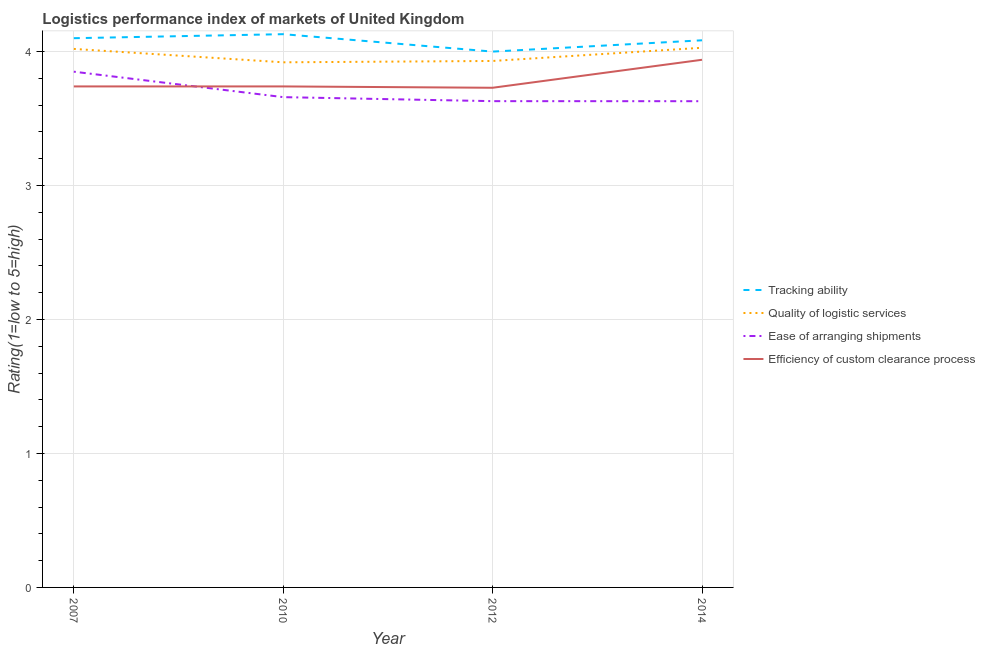How many different coloured lines are there?
Offer a terse response. 4. Is the number of lines equal to the number of legend labels?
Provide a succinct answer. Yes. What is the lpi rating of tracking ability in 2012?
Your answer should be compact. 4. Across all years, what is the maximum lpi rating of tracking ability?
Provide a succinct answer. 4.13. What is the total lpi rating of ease of arranging shipments in the graph?
Offer a terse response. 14.77. What is the difference between the lpi rating of ease of arranging shipments in 2007 and that in 2014?
Provide a succinct answer. 0.22. What is the difference between the lpi rating of tracking ability in 2012 and the lpi rating of efficiency of custom clearance process in 2010?
Give a very brief answer. 0.26. What is the average lpi rating of quality of logistic services per year?
Ensure brevity in your answer.  3.97. In the year 2012, what is the difference between the lpi rating of tracking ability and lpi rating of efficiency of custom clearance process?
Keep it short and to the point. 0.27. In how many years, is the lpi rating of tracking ability greater than 3?
Provide a succinct answer. 4. What is the ratio of the lpi rating of efficiency of custom clearance process in 2010 to that in 2014?
Ensure brevity in your answer.  0.95. Is the lpi rating of ease of arranging shipments in 2007 less than that in 2010?
Give a very brief answer. No. What is the difference between the highest and the second highest lpi rating of tracking ability?
Ensure brevity in your answer.  0.03. What is the difference between the highest and the lowest lpi rating of ease of arranging shipments?
Provide a short and direct response. 0.22. In how many years, is the lpi rating of efficiency of custom clearance process greater than the average lpi rating of efficiency of custom clearance process taken over all years?
Your answer should be compact. 1. Is it the case that in every year, the sum of the lpi rating of tracking ability and lpi rating of quality of logistic services is greater than the lpi rating of ease of arranging shipments?
Offer a very short reply. Yes. How many lines are there?
Provide a succinct answer. 4. What is the difference between two consecutive major ticks on the Y-axis?
Your response must be concise. 1. Are the values on the major ticks of Y-axis written in scientific E-notation?
Your answer should be compact. No. Does the graph contain any zero values?
Your response must be concise. No. Where does the legend appear in the graph?
Give a very brief answer. Center right. How are the legend labels stacked?
Ensure brevity in your answer.  Vertical. What is the title of the graph?
Your answer should be compact. Logistics performance index of markets of United Kingdom. What is the label or title of the X-axis?
Your response must be concise. Year. What is the label or title of the Y-axis?
Keep it short and to the point. Rating(1=low to 5=high). What is the Rating(1=low to 5=high) in Tracking ability in 2007?
Your response must be concise. 4.1. What is the Rating(1=low to 5=high) in Quality of logistic services in 2007?
Give a very brief answer. 4.02. What is the Rating(1=low to 5=high) of Ease of arranging shipments in 2007?
Keep it short and to the point. 3.85. What is the Rating(1=low to 5=high) of Efficiency of custom clearance process in 2007?
Provide a short and direct response. 3.74. What is the Rating(1=low to 5=high) of Tracking ability in 2010?
Give a very brief answer. 4.13. What is the Rating(1=low to 5=high) in Quality of logistic services in 2010?
Your response must be concise. 3.92. What is the Rating(1=low to 5=high) in Ease of arranging shipments in 2010?
Make the answer very short. 3.66. What is the Rating(1=low to 5=high) of Efficiency of custom clearance process in 2010?
Provide a succinct answer. 3.74. What is the Rating(1=low to 5=high) in Tracking ability in 2012?
Give a very brief answer. 4. What is the Rating(1=low to 5=high) in Quality of logistic services in 2012?
Ensure brevity in your answer.  3.93. What is the Rating(1=low to 5=high) of Ease of arranging shipments in 2012?
Provide a short and direct response. 3.63. What is the Rating(1=low to 5=high) of Efficiency of custom clearance process in 2012?
Your answer should be very brief. 3.73. What is the Rating(1=low to 5=high) in Tracking ability in 2014?
Your response must be concise. 4.08. What is the Rating(1=low to 5=high) in Quality of logistic services in 2014?
Give a very brief answer. 4.03. What is the Rating(1=low to 5=high) of Ease of arranging shipments in 2014?
Offer a terse response. 3.63. What is the Rating(1=low to 5=high) in Efficiency of custom clearance process in 2014?
Make the answer very short. 3.94. Across all years, what is the maximum Rating(1=low to 5=high) in Tracking ability?
Make the answer very short. 4.13. Across all years, what is the maximum Rating(1=low to 5=high) of Quality of logistic services?
Your answer should be very brief. 4.03. Across all years, what is the maximum Rating(1=low to 5=high) of Ease of arranging shipments?
Provide a short and direct response. 3.85. Across all years, what is the maximum Rating(1=low to 5=high) in Efficiency of custom clearance process?
Make the answer very short. 3.94. Across all years, what is the minimum Rating(1=low to 5=high) in Tracking ability?
Give a very brief answer. 4. Across all years, what is the minimum Rating(1=low to 5=high) in Quality of logistic services?
Provide a succinct answer. 3.92. Across all years, what is the minimum Rating(1=low to 5=high) in Ease of arranging shipments?
Make the answer very short. 3.63. Across all years, what is the minimum Rating(1=low to 5=high) of Efficiency of custom clearance process?
Your response must be concise. 3.73. What is the total Rating(1=low to 5=high) in Tracking ability in the graph?
Offer a very short reply. 16.31. What is the total Rating(1=low to 5=high) in Quality of logistic services in the graph?
Ensure brevity in your answer.  15.9. What is the total Rating(1=low to 5=high) in Ease of arranging shipments in the graph?
Provide a succinct answer. 14.77. What is the total Rating(1=low to 5=high) of Efficiency of custom clearance process in the graph?
Keep it short and to the point. 15.15. What is the difference between the Rating(1=low to 5=high) in Tracking ability in 2007 and that in 2010?
Give a very brief answer. -0.03. What is the difference between the Rating(1=low to 5=high) in Ease of arranging shipments in 2007 and that in 2010?
Provide a short and direct response. 0.19. What is the difference between the Rating(1=low to 5=high) of Quality of logistic services in 2007 and that in 2012?
Provide a short and direct response. 0.09. What is the difference between the Rating(1=low to 5=high) of Ease of arranging shipments in 2007 and that in 2012?
Your answer should be compact. 0.22. What is the difference between the Rating(1=low to 5=high) of Efficiency of custom clearance process in 2007 and that in 2012?
Make the answer very short. 0.01. What is the difference between the Rating(1=low to 5=high) of Tracking ability in 2007 and that in 2014?
Your answer should be very brief. 0.02. What is the difference between the Rating(1=low to 5=high) in Quality of logistic services in 2007 and that in 2014?
Your answer should be very brief. -0.01. What is the difference between the Rating(1=low to 5=high) of Ease of arranging shipments in 2007 and that in 2014?
Your answer should be compact. 0.22. What is the difference between the Rating(1=low to 5=high) of Efficiency of custom clearance process in 2007 and that in 2014?
Ensure brevity in your answer.  -0.2. What is the difference between the Rating(1=low to 5=high) in Tracking ability in 2010 and that in 2012?
Offer a very short reply. 0.13. What is the difference between the Rating(1=low to 5=high) of Quality of logistic services in 2010 and that in 2012?
Make the answer very short. -0.01. What is the difference between the Rating(1=low to 5=high) of Tracking ability in 2010 and that in 2014?
Give a very brief answer. 0.05. What is the difference between the Rating(1=low to 5=high) of Quality of logistic services in 2010 and that in 2014?
Offer a terse response. -0.11. What is the difference between the Rating(1=low to 5=high) of Ease of arranging shipments in 2010 and that in 2014?
Provide a succinct answer. 0.03. What is the difference between the Rating(1=low to 5=high) of Efficiency of custom clearance process in 2010 and that in 2014?
Ensure brevity in your answer.  -0.2. What is the difference between the Rating(1=low to 5=high) of Tracking ability in 2012 and that in 2014?
Provide a short and direct response. -0.08. What is the difference between the Rating(1=low to 5=high) of Quality of logistic services in 2012 and that in 2014?
Keep it short and to the point. -0.1. What is the difference between the Rating(1=low to 5=high) of Efficiency of custom clearance process in 2012 and that in 2014?
Give a very brief answer. -0.21. What is the difference between the Rating(1=low to 5=high) in Tracking ability in 2007 and the Rating(1=low to 5=high) in Quality of logistic services in 2010?
Your answer should be compact. 0.18. What is the difference between the Rating(1=low to 5=high) in Tracking ability in 2007 and the Rating(1=low to 5=high) in Ease of arranging shipments in 2010?
Keep it short and to the point. 0.44. What is the difference between the Rating(1=low to 5=high) in Tracking ability in 2007 and the Rating(1=low to 5=high) in Efficiency of custom clearance process in 2010?
Provide a short and direct response. 0.36. What is the difference between the Rating(1=low to 5=high) of Quality of logistic services in 2007 and the Rating(1=low to 5=high) of Ease of arranging shipments in 2010?
Give a very brief answer. 0.36. What is the difference between the Rating(1=low to 5=high) of Quality of logistic services in 2007 and the Rating(1=low to 5=high) of Efficiency of custom clearance process in 2010?
Give a very brief answer. 0.28. What is the difference between the Rating(1=low to 5=high) of Ease of arranging shipments in 2007 and the Rating(1=low to 5=high) of Efficiency of custom clearance process in 2010?
Ensure brevity in your answer.  0.11. What is the difference between the Rating(1=low to 5=high) in Tracking ability in 2007 and the Rating(1=low to 5=high) in Quality of logistic services in 2012?
Your response must be concise. 0.17. What is the difference between the Rating(1=low to 5=high) in Tracking ability in 2007 and the Rating(1=low to 5=high) in Ease of arranging shipments in 2012?
Your response must be concise. 0.47. What is the difference between the Rating(1=low to 5=high) of Tracking ability in 2007 and the Rating(1=low to 5=high) of Efficiency of custom clearance process in 2012?
Provide a short and direct response. 0.37. What is the difference between the Rating(1=low to 5=high) of Quality of logistic services in 2007 and the Rating(1=low to 5=high) of Ease of arranging shipments in 2012?
Your answer should be very brief. 0.39. What is the difference between the Rating(1=low to 5=high) in Quality of logistic services in 2007 and the Rating(1=low to 5=high) in Efficiency of custom clearance process in 2012?
Make the answer very short. 0.29. What is the difference between the Rating(1=low to 5=high) of Ease of arranging shipments in 2007 and the Rating(1=low to 5=high) of Efficiency of custom clearance process in 2012?
Make the answer very short. 0.12. What is the difference between the Rating(1=low to 5=high) in Tracking ability in 2007 and the Rating(1=low to 5=high) in Quality of logistic services in 2014?
Your answer should be compact. 0.07. What is the difference between the Rating(1=low to 5=high) in Tracking ability in 2007 and the Rating(1=low to 5=high) in Ease of arranging shipments in 2014?
Give a very brief answer. 0.47. What is the difference between the Rating(1=low to 5=high) of Tracking ability in 2007 and the Rating(1=low to 5=high) of Efficiency of custom clearance process in 2014?
Your answer should be compact. 0.16. What is the difference between the Rating(1=low to 5=high) in Quality of logistic services in 2007 and the Rating(1=low to 5=high) in Ease of arranging shipments in 2014?
Make the answer very short. 0.39. What is the difference between the Rating(1=low to 5=high) of Quality of logistic services in 2007 and the Rating(1=low to 5=high) of Efficiency of custom clearance process in 2014?
Your response must be concise. 0.08. What is the difference between the Rating(1=low to 5=high) of Ease of arranging shipments in 2007 and the Rating(1=low to 5=high) of Efficiency of custom clearance process in 2014?
Provide a succinct answer. -0.09. What is the difference between the Rating(1=low to 5=high) in Tracking ability in 2010 and the Rating(1=low to 5=high) in Quality of logistic services in 2012?
Offer a terse response. 0.2. What is the difference between the Rating(1=low to 5=high) in Tracking ability in 2010 and the Rating(1=low to 5=high) in Ease of arranging shipments in 2012?
Offer a terse response. 0.5. What is the difference between the Rating(1=low to 5=high) in Tracking ability in 2010 and the Rating(1=low to 5=high) in Efficiency of custom clearance process in 2012?
Offer a terse response. 0.4. What is the difference between the Rating(1=low to 5=high) in Quality of logistic services in 2010 and the Rating(1=low to 5=high) in Ease of arranging shipments in 2012?
Offer a terse response. 0.29. What is the difference between the Rating(1=low to 5=high) in Quality of logistic services in 2010 and the Rating(1=low to 5=high) in Efficiency of custom clearance process in 2012?
Your answer should be compact. 0.19. What is the difference between the Rating(1=low to 5=high) in Ease of arranging shipments in 2010 and the Rating(1=low to 5=high) in Efficiency of custom clearance process in 2012?
Keep it short and to the point. -0.07. What is the difference between the Rating(1=low to 5=high) in Tracking ability in 2010 and the Rating(1=low to 5=high) in Quality of logistic services in 2014?
Give a very brief answer. 0.1. What is the difference between the Rating(1=low to 5=high) in Tracking ability in 2010 and the Rating(1=low to 5=high) in Ease of arranging shipments in 2014?
Offer a terse response. 0.5. What is the difference between the Rating(1=low to 5=high) of Tracking ability in 2010 and the Rating(1=low to 5=high) of Efficiency of custom clearance process in 2014?
Keep it short and to the point. 0.19. What is the difference between the Rating(1=low to 5=high) in Quality of logistic services in 2010 and the Rating(1=low to 5=high) in Ease of arranging shipments in 2014?
Offer a very short reply. 0.29. What is the difference between the Rating(1=low to 5=high) in Quality of logistic services in 2010 and the Rating(1=low to 5=high) in Efficiency of custom clearance process in 2014?
Provide a short and direct response. -0.02. What is the difference between the Rating(1=low to 5=high) of Ease of arranging shipments in 2010 and the Rating(1=low to 5=high) of Efficiency of custom clearance process in 2014?
Give a very brief answer. -0.28. What is the difference between the Rating(1=low to 5=high) of Tracking ability in 2012 and the Rating(1=low to 5=high) of Quality of logistic services in 2014?
Ensure brevity in your answer.  -0.03. What is the difference between the Rating(1=low to 5=high) in Tracking ability in 2012 and the Rating(1=low to 5=high) in Ease of arranging shipments in 2014?
Provide a short and direct response. 0.37. What is the difference between the Rating(1=low to 5=high) of Tracking ability in 2012 and the Rating(1=low to 5=high) of Efficiency of custom clearance process in 2014?
Make the answer very short. 0.06. What is the difference between the Rating(1=low to 5=high) of Quality of logistic services in 2012 and the Rating(1=low to 5=high) of Ease of arranging shipments in 2014?
Provide a succinct answer. 0.3. What is the difference between the Rating(1=low to 5=high) of Quality of logistic services in 2012 and the Rating(1=low to 5=high) of Efficiency of custom clearance process in 2014?
Keep it short and to the point. -0.01. What is the difference between the Rating(1=low to 5=high) of Ease of arranging shipments in 2012 and the Rating(1=low to 5=high) of Efficiency of custom clearance process in 2014?
Your answer should be very brief. -0.31. What is the average Rating(1=low to 5=high) in Tracking ability per year?
Make the answer very short. 4.08. What is the average Rating(1=low to 5=high) of Quality of logistic services per year?
Provide a short and direct response. 3.97. What is the average Rating(1=low to 5=high) in Ease of arranging shipments per year?
Offer a very short reply. 3.69. What is the average Rating(1=low to 5=high) of Efficiency of custom clearance process per year?
Give a very brief answer. 3.79. In the year 2007, what is the difference between the Rating(1=low to 5=high) in Tracking ability and Rating(1=low to 5=high) in Quality of logistic services?
Make the answer very short. 0.08. In the year 2007, what is the difference between the Rating(1=low to 5=high) in Tracking ability and Rating(1=low to 5=high) in Ease of arranging shipments?
Keep it short and to the point. 0.25. In the year 2007, what is the difference between the Rating(1=low to 5=high) in Tracking ability and Rating(1=low to 5=high) in Efficiency of custom clearance process?
Provide a short and direct response. 0.36. In the year 2007, what is the difference between the Rating(1=low to 5=high) in Quality of logistic services and Rating(1=low to 5=high) in Ease of arranging shipments?
Offer a terse response. 0.17. In the year 2007, what is the difference between the Rating(1=low to 5=high) in Quality of logistic services and Rating(1=low to 5=high) in Efficiency of custom clearance process?
Keep it short and to the point. 0.28. In the year 2007, what is the difference between the Rating(1=low to 5=high) in Ease of arranging shipments and Rating(1=low to 5=high) in Efficiency of custom clearance process?
Your answer should be compact. 0.11. In the year 2010, what is the difference between the Rating(1=low to 5=high) of Tracking ability and Rating(1=low to 5=high) of Quality of logistic services?
Give a very brief answer. 0.21. In the year 2010, what is the difference between the Rating(1=low to 5=high) in Tracking ability and Rating(1=low to 5=high) in Ease of arranging shipments?
Your answer should be compact. 0.47. In the year 2010, what is the difference between the Rating(1=low to 5=high) in Tracking ability and Rating(1=low to 5=high) in Efficiency of custom clearance process?
Ensure brevity in your answer.  0.39. In the year 2010, what is the difference between the Rating(1=low to 5=high) of Quality of logistic services and Rating(1=low to 5=high) of Ease of arranging shipments?
Your answer should be compact. 0.26. In the year 2010, what is the difference between the Rating(1=low to 5=high) of Quality of logistic services and Rating(1=low to 5=high) of Efficiency of custom clearance process?
Provide a succinct answer. 0.18. In the year 2010, what is the difference between the Rating(1=low to 5=high) of Ease of arranging shipments and Rating(1=low to 5=high) of Efficiency of custom clearance process?
Your response must be concise. -0.08. In the year 2012, what is the difference between the Rating(1=low to 5=high) in Tracking ability and Rating(1=low to 5=high) in Quality of logistic services?
Your response must be concise. 0.07. In the year 2012, what is the difference between the Rating(1=low to 5=high) of Tracking ability and Rating(1=low to 5=high) of Ease of arranging shipments?
Make the answer very short. 0.37. In the year 2012, what is the difference between the Rating(1=low to 5=high) of Tracking ability and Rating(1=low to 5=high) of Efficiency of custom clearance process?
Provide a succinct answer. 0.27. In the year 2012, what is the difference between the Rating(1=low to 5=high) of Quality of logistic services and Rating(1=low to 5=high) of Ease of arranging shipments?
Provide a succinct answer. 0.3. In the year 2012, what is the difference between the Rating(1=low to 5=high) of Ease of arranging shipments and Rating(1=low to 5=high) of Efficiency of custom clearance process?
Provide a short and direct response. -0.1. In the year 2014, what is the difference between the Rating(1=low to 5=high) in Tracking ability and Rating(1=low to 5=high) in Quality of logistic services?
Give a very brief answer. 0.06. In the year 2014, what is the difference between the Rating(1=low to 5=high) in Tracking ability and Rating(1=low to 5=high) in Ease of arranging shipments?
Ensure brevity in your answer.  0.45. In the year 2014, what is the difference between the Rating(1=low to 5=high) of Tracking ability and Rating(1=low to 5=high) of Efficiency of custom clearance process?
Provide a short and direct response. 0.15. In the year 2014, what is the difference between the Rating(1=low to 5=high) in Quality of logistic services and Rating(1=low to 5=high) in Ease of arranging shipments?
Provide a succinct answer. 0.4. In the year 2014, what is the difference between the Rating(1=low to 5=high) of Quality of logistic services and Rating(1=low to 5=high) of Efficiency of custom clearance process?
Your response must be concise. 0.09. In the year 2014, what is the difference between the Rating(1=low to 5=high) of Ease of arranging shipments and Rating(1=low to 5=high) of Efficiency of custom clearance process?
Offer a terse response. -0.31. What is the ratio of the Rating(1=low to 5=high) in Tracking ability in 2007 to that in 2010?
Give a very brief answer. 0.99. What is the ratio of the Rating(1=low to 5=high) in Quality of logistic services in 2007 to that in 2010?
Give a very brief answer. 1.03. What is the ratio of the Rating(1=low to 5=high) of Ease of arranging shipments in 2007 to that in 2010?
Provide a succinct answer. 1.05. What is the ratio of the Rating(1=low to 5=high) of Quality of logistic services in 2007 to that in 2012?
Your answer should be very brief. 1.02. What is the ratio of the Rating(1=low to 5=high) in Ease of arranging shipments in 2007 to that in 2012?
Provide a short and direct response. 1.06. What is the ratio of the Rating(1=low to 5=high) in Efficiency of custom clearance process in 2007 to that in 2012?
Keep it short and to the point. 1. What is the ratio of the Rating(1=low to 5=high) in Quality of logistic services in 2007 to that in 2014?
Provide a succinct answer. 1. What is the ratio of the Rating(1=low to 5=high) in Ease of arranging shipments in 2007 to that in 2014?
Keep it short and to the point. 1.06. What is the ratio of the Rating(1=low to 5=high) of Efficiency of custom clearance process in 2007 to that in 2014?
Offer a terse response. 0.95. What is the ratio of the Rating(1=low to 5=high) in Tracking ability in 2010 to that in 2012?
Your answer should be compact. 1.03. What is the ratio of the Rating(1=low to 5=high) of Quality of logistic services in 2010 to that in 2012?
Provide a short and direct response. 1. What is the ratio of the Rating(1=low to 5=high) in Ease of arranging shipments in 2010 to that in 2012?
Offer a very short reply. 1.01. What is the ratio of the Rating(1=low to 5=high) in Efficiency of custom clearance process in 2010 to that in 2012?
Your answer should be very brief. 1. What is the ratio of the Rating(1=low to 5=high) of Tracking ability in 2010 to that in 2014?
Your answer should be very brief. 1.01. What is the ratio of the Rating(1=low to 5=high) in Quality of logistic services in 2010 to that in 2014?
Your answer should be very brief. 0.97. What is the ratio of the Rating(1=low to 5=high) of Ease of arranging shipments in 2010 to that in 2014?
Make the answer very short. 1.01. What is the ratio of the Rating(1=low to 5=high) of Efficiency of custom clearance process in 2010 to that in 2014?
Your answer should be compact. 0.95. What is the ratio of the Rating(1=low to 5=high) of Tracking ability in 2012 to that in 2014?
Ensure brevity in your answer.  0.98. What is the ratio of the Rating(1=low to 5=high) of Quality of logistic services in 2012 to that in 2014?
Make the answer very short. 0.98. What is the ratio of the Rating(1=low to 5=high) of Efficiency of custom clearance process in 2012 to that in 2014?
Give a very brief answer. 0.95. What is the difference between the highest and the second highest Rating(1=low to 5=high) in Quality of logistic services?
Your answer should be compact. 0.01. What is the difference between the highest and the second highest Rating(1=low to 5=high) in Ease of arranging shipments?
Offer a very short reply. 0.19. What is the difference between the highest and the second highest Rating(1=low to 5=high) in Efficiency of custom clearance process?
Your answer should be compact. 0.2. What is the difference between the highest and the lowest Rating(1=low to 5=high) in Tracking ability?
Provide a succinct answer. 0.13. What is the difference between the highest and the lowest Rating(1=low to 5=high) in Quality of logistic services?
Ensure brevity in your answer.  0.11. What is the difference between the highest and the lowest Rating(1=low to 5=high) of Ease of arranging shipments?
Provide a succinct answer. 0.22. What is the difference between the highest and the lowest Rating(1=low to 5=high) in Efficiency of custom clearance process?
Ensure brevity in your answer.  0.21. 